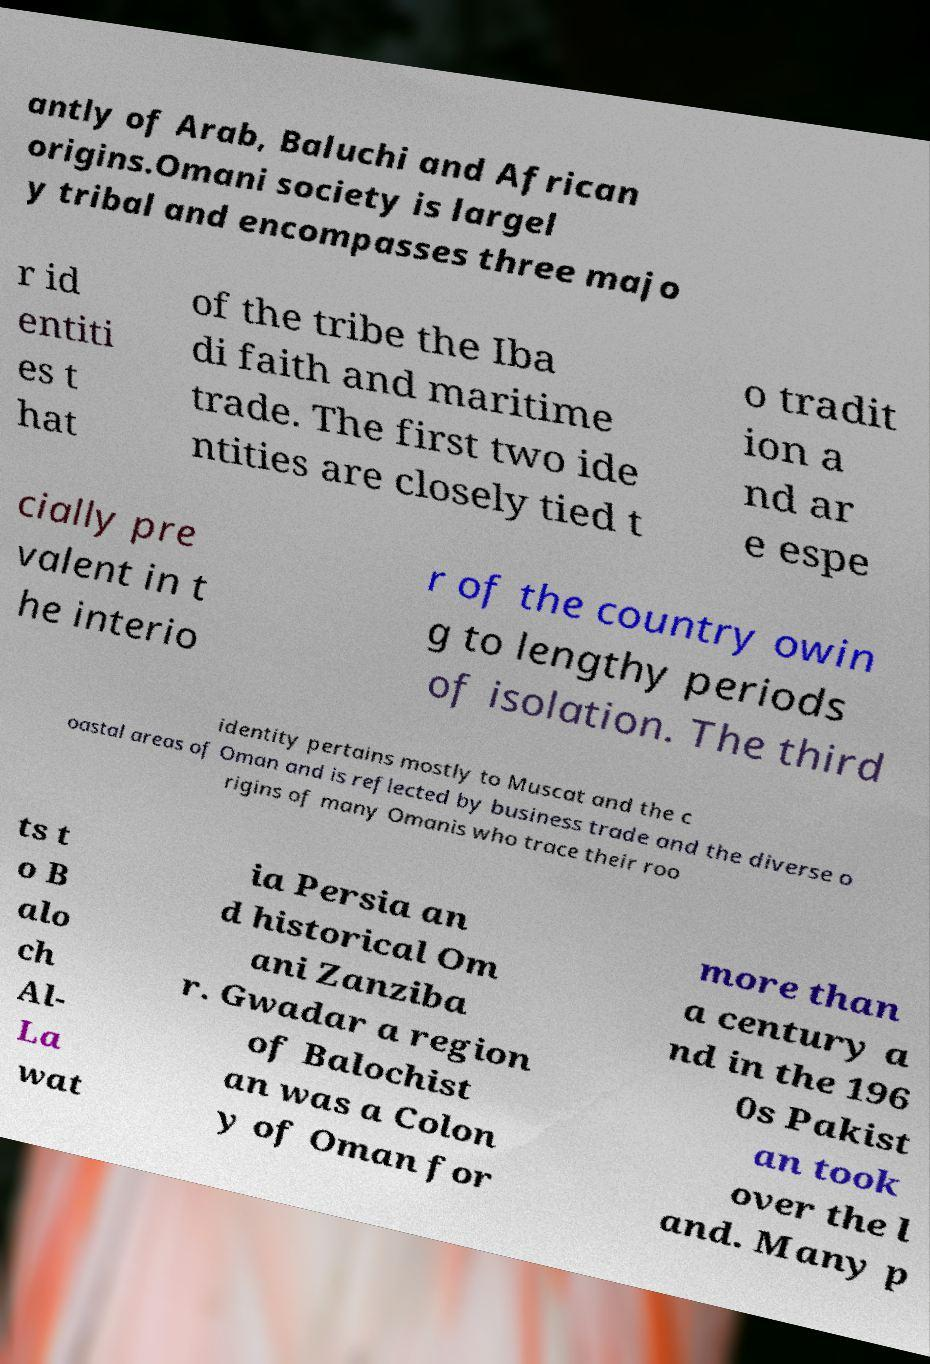Could you extract and type out the text from this image? antly of Arab, Baluchi and African origins.Omani society is largel y tribal and encompasses three majo r id entiti es t hat of the tribe the Iba di faith and maritime trade. The first two ide ntities are closely tied t o tradit ion a nd ar e espe cially pre valent in t he interio r of the country owin g to lengthy periods of isolation. The third identity pertains mostly to Muscat and the c oastal areas of Oman and is reflected by business trade and the diverse o rigins of many Omanis who trace their roo ts t o B alo ch Al- La wat ia Persia an d historical Om ani Zanziba r. Gwadar a region of Balochist an was a Colon y of Oman for more than a century a nd in the 196 0s Pakist an took over the l and. Many p 